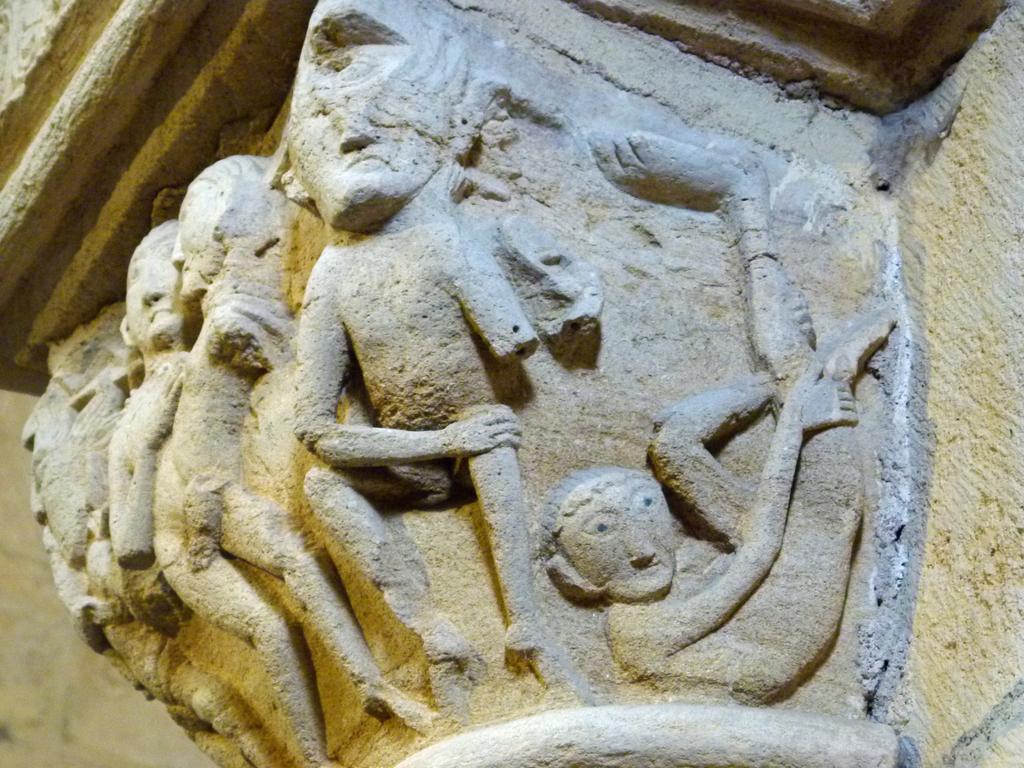Could you give a brief overview of what you see in this image? In the picture I can see sculptures on the wall. 